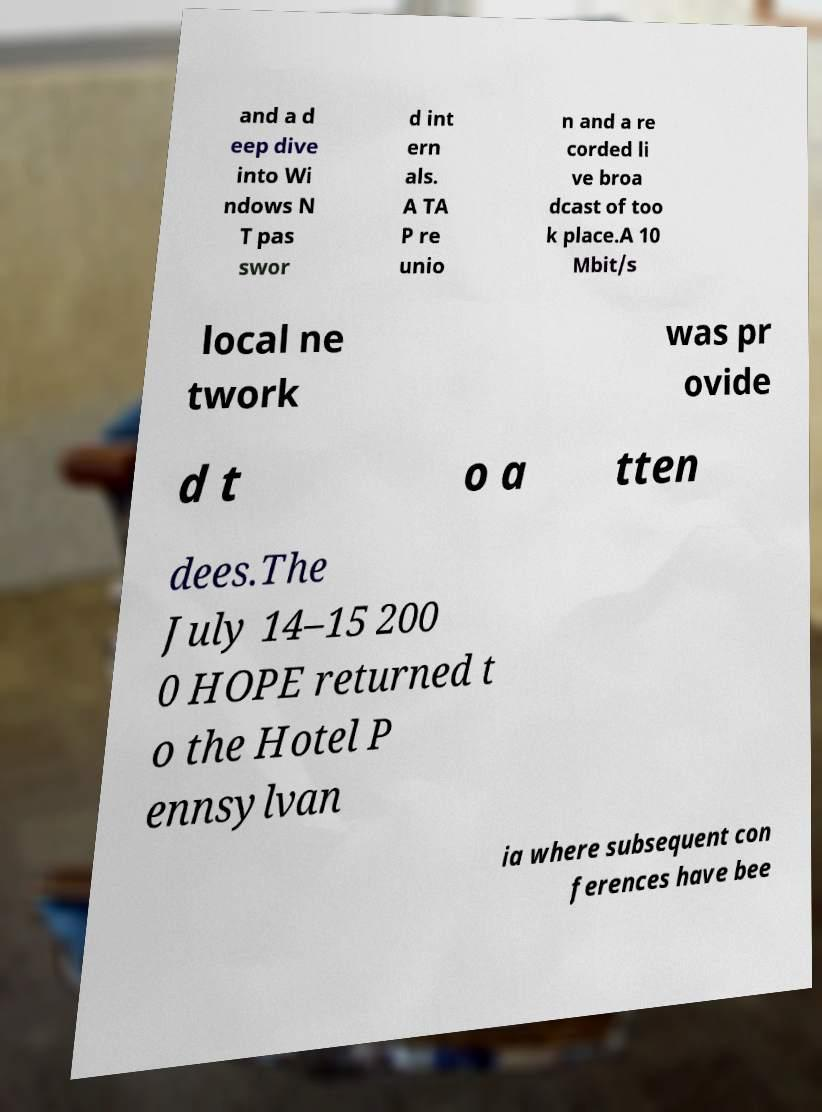I need the written content from this picture converted into text. Can you do that? and a d eep dive into Wi ndows N T pas swor d int ern als. A TA P re unio n and a re corded li ve broa dcast of too k place.A 10 Mbit/s local ne twork was pr ovide d t o a tten dees.The July 14–15 200 0 HOPE returned t o the Hotel P ennsylvan ia where subsequent con ferences have bee 